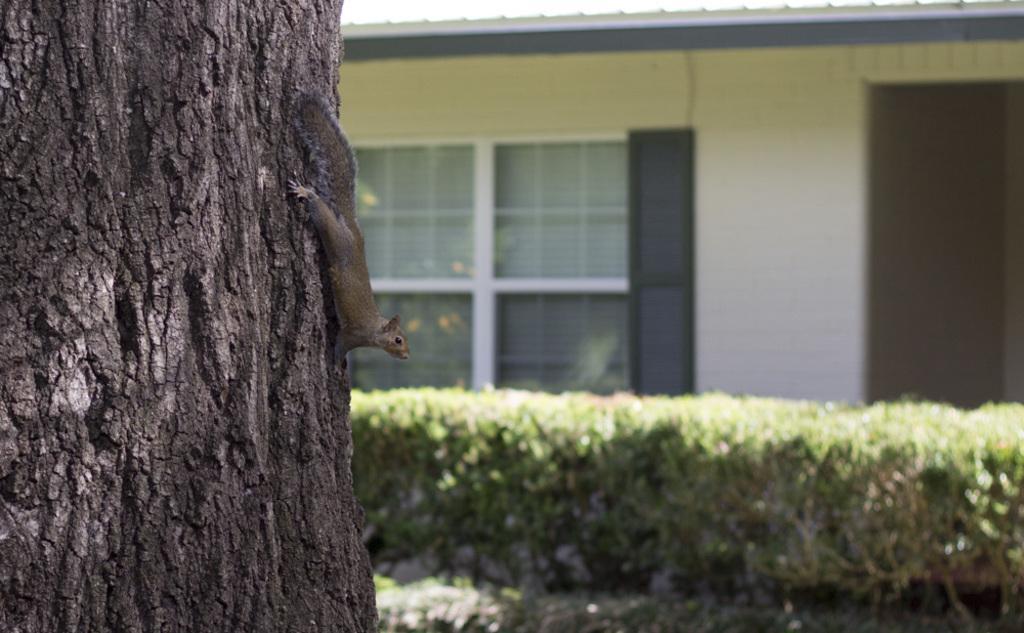Describe this image in one or two sentences. In this picture we can see a squirrel on a tree trunk and in the background we can see plants, wall and some objects. 